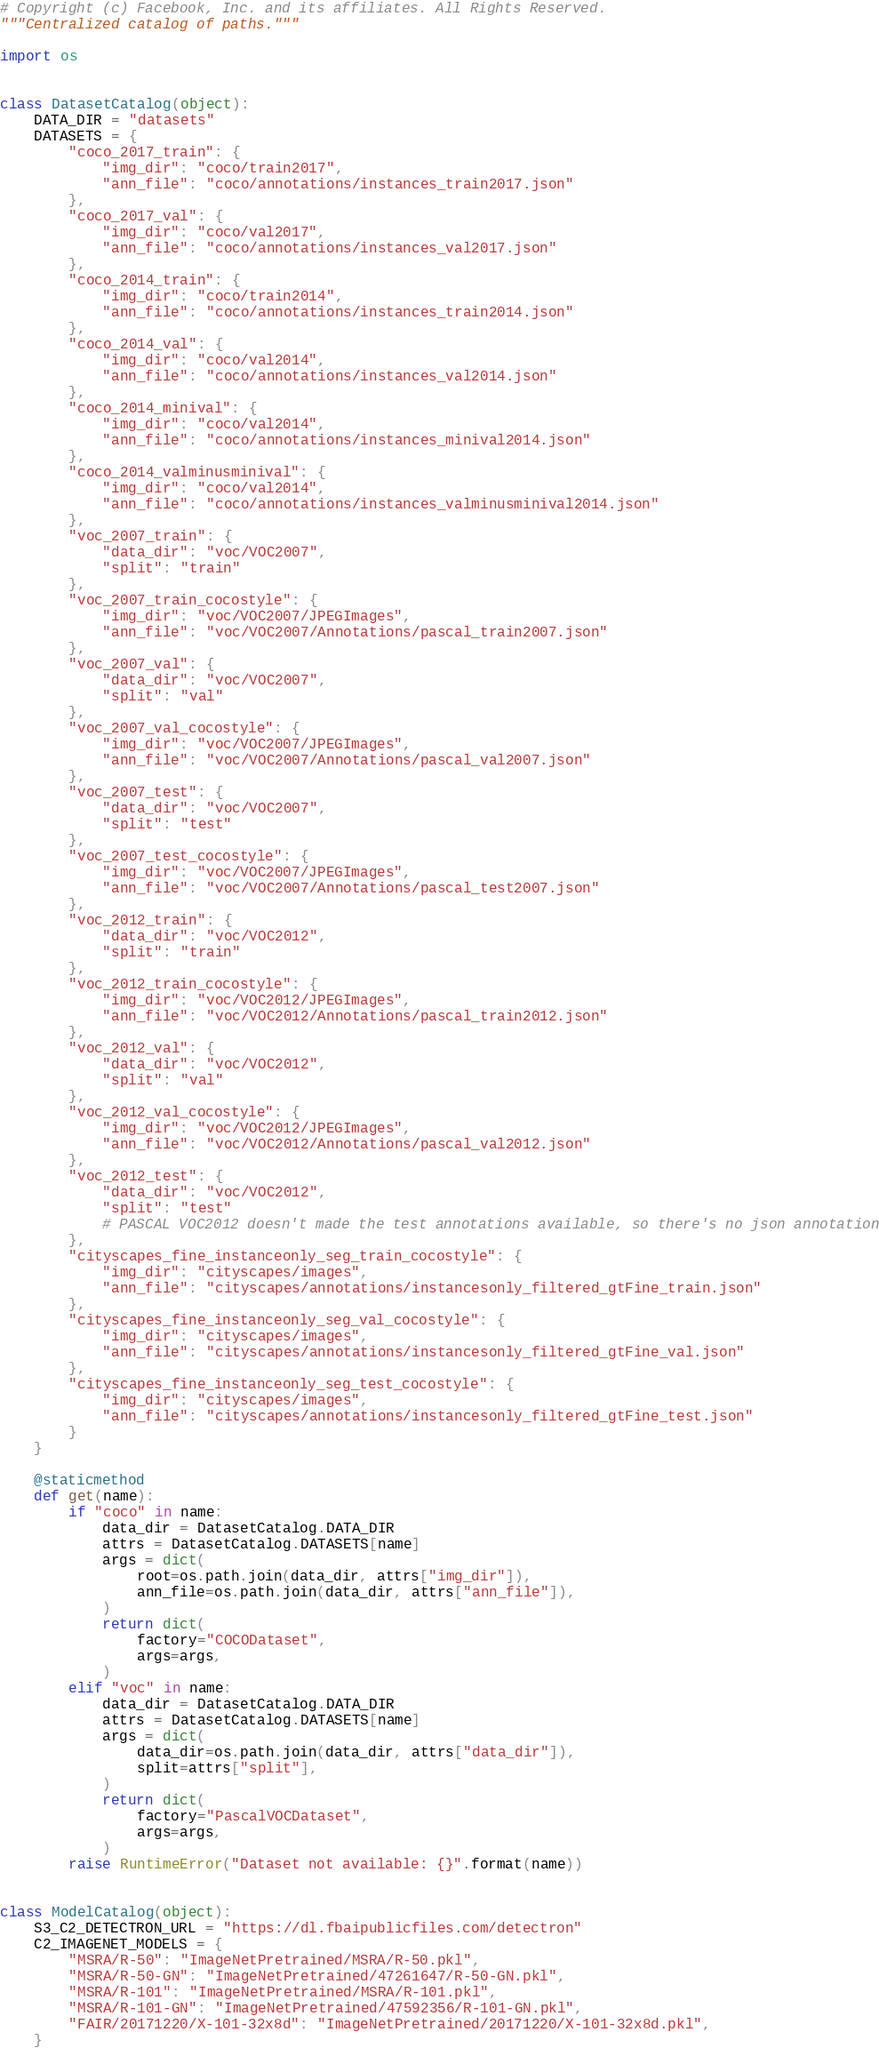Convert code to text. <code><loc_0><loc_0><loc_500><loc_500><_Python_># Copyright (c) Facebook, Inc. and its affiliates. All Rights Reserved.
"""Centralized catalog of paths."""

import os


class DatasetCatalog(object):
    DATA_DIR = "datasets"
    DATASETS = {
        "coco_2017_train": {
            "img_dir": "coco/train2017",
            "ann_file": "coco/annotations/instances_train2017.json"
        },
        "coco_2017_val": {
            "img_dir": "coco/val2017",
            "ann_file": "coco/annotations/instances_val2017.json"
        },
        "coco_2014_train": {
            "img_dir": "coco/train2014",
            "ann_file": "coco/annotations/instances_train2014.json"
        },
        "coco_2014_val": {
            "img_dir": "coco/val2014",
            "ann_file": "coco/annotations/instances_val2014.json"
        },
        "coco_2014_minival": {
            "img_dir": "coco/val2014",
            "ann_file": "coco/annotations/instances_minival2014.json"
        },
        "coco_2014_valminusminival": {
            "img_dir": "coco/val2014",
            "ann_file": "coco/annotations/instances_valminusminival2014.json"
        },
        "voc_2007_train": {
            "data_dir": "voc/VOC2007",
            "split": "train"
        },
        "voc_2007_train_cocostyle": {
            "img_dir": "voc/VOC2007/JPEGImages",
            "ann_file": "voc/VOC2007/Annotations/pascal_train2007.json"
        },
        "voc_2007_val": {
            "data_dir": "voc/VOC2007",
            "split": "val"
        },
        "voc_2007_val_cocostyle": {
            "img_dir": "voc/VOC2007/JPEGImages",
            "ann_file": "voc/VOC2007/Annotations/pascal_val2007.json"
        },
        "voc_2007_test": {
            "data_dir": "voc/VOC2007",
            "split": "test"
        },
        "voc_2007_test_cocostyle": {
            "img_dir": "voc/VOC2007/JPEGImages",
            "ann_file": "voc/VOC2007/Annotations/pascal_test2007.json"
        },
        "voc_2012_train": {
            "data_dir": "voc/VOC2012",
            "split": "train"
        },
        "voc_2012_train_cocostyle": {
            "img_dir": "voc/VOC2012/JPEGImages",
            "ann_file": "voc/VOC2012/Annotations/pascal_train2012.json"
        },
        "voc_2012_val": {
            "data_dir": "voc/VOC2012",
            "split": "val"
        },
        "voc_2012_val_cocostyle": {
            "img_dir": "voc/VOC2012/JPEGImages",
            "ann_file": "voc/VOC2012/Annotations/pascal_val2012.json"
        },
        "voc_2012_test": {
            "data_dir": "voc/VOC2012",
            "split": "test"
            # PASCAL VOC2012 doesn't made the test annotations available, so there's no json annotation
        },
        "cityscapes_fine_instanceonly_seg_train_cocostyle": {
            "img_dir": "cityscapes/images",
            "ann_file": "cityscapes/annotations/instancesonly_filtered_gtFine_train.json"
        },
        "cityscapes_fine_instanceonly_seg_val_cocostyle": {
            "img_dir": "cityscapes/images",
            "ann_file": "cityscapes/annotations/instancesonly_filtered_gtFine_val.json"
        },
        "cityscapes_fine_instanceonly_seg_test_cocostyle": {
            "img_dir": "cityscapes/images",
            "ann_file": "cityscapes/annotations/instancesonly_filtered_gtFine_test.json"
        }
    }

    @staticmethod
    def get(name):
        if "coco" in name:
            data_dir = DatasetCatalog.DATA_DIR
            attrs = DatasetCatalog.DATASETS[name]
            args = dict(
                root=os.path.join(data_dir, attrs["img_dir"]),
                ann_file=os.path.join(data_dir, attrs["ann_file"]),
            )
            return dict(
                factory="COCODataset",
                args=args,
            )
        elif "voc" in name:
            data_dir = DatasetCatalog.DATA_DIR
            attrs = DatasetCatalog.DATASETS[name]
            args = dict(
                data_dir=os.path.join(data_dir, attrs["data_dir"]),
                split=attrs["split"],
            )
            return dict(
                factory="PascalVOCDataset",
                args=args,
            )
        raise RuntimeError("Dataset not available: {}".format(name))


class ModelCatalog(object):
    S3_C2_DETECTRON_URL = "https://dl.fbaipublicfiles.com/detectron"
    C2_IMAGENET_MODELS = {
        "MSRA/R-50": "ImageNetPretrained/MSRA/R-50.pkl",
        "MSRA/R-50-GN": "ImageNetPretrained/47261647/R-50-GN.pkl",
        "MSRA/R-101": "ImageNetPretrained/MSRA/R-101.pkl",
        "MSRA/R-101-GN": "ImageNetPretrained/47592356/R-101-GN.pkl",
        "FAIR/20171220/X-101-32x8d": "ImageNetPretrained/20171220/X-101-32x8d.pkl",
    }
</code> 